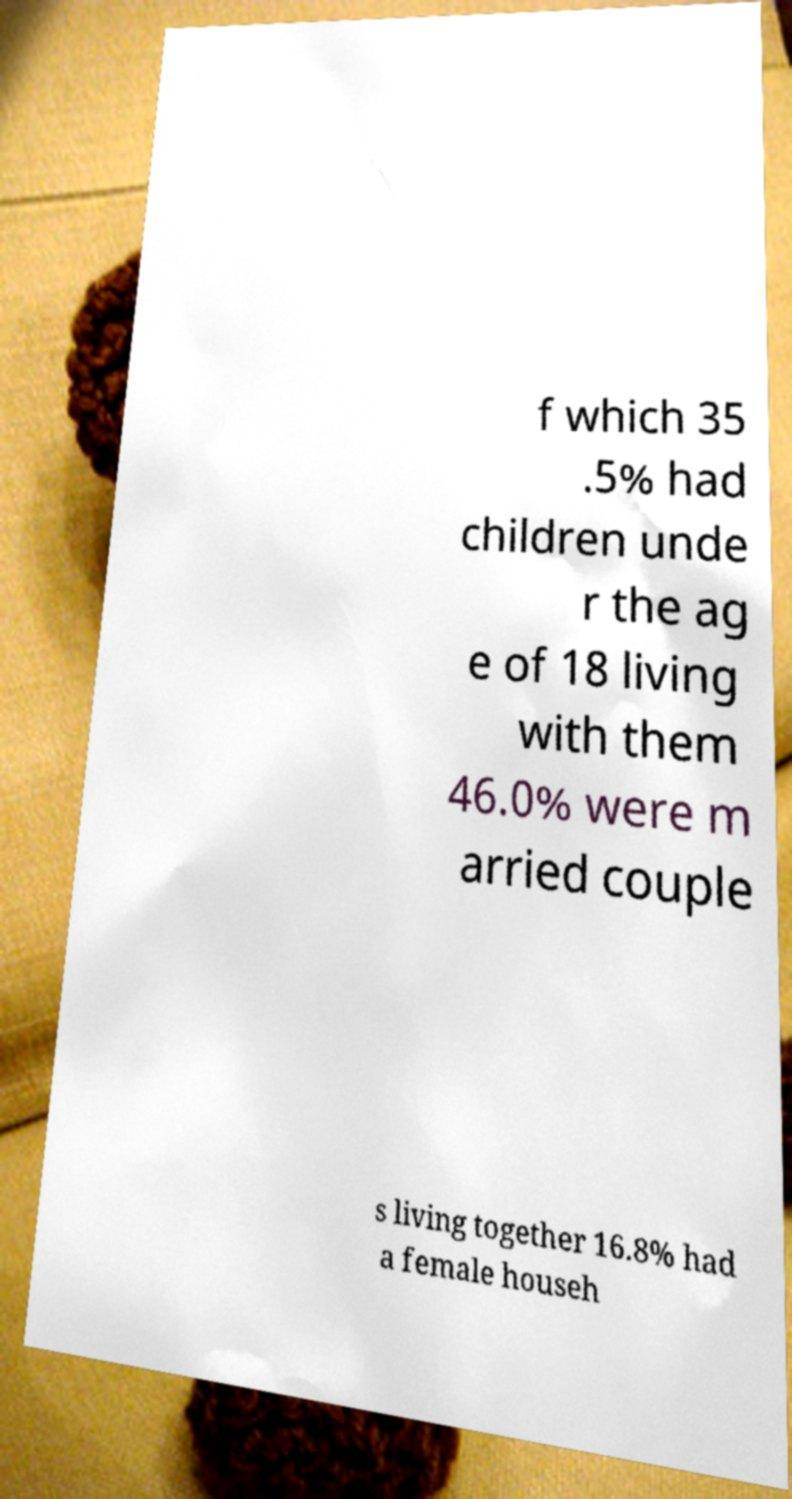There's text embedded in this image that I need extracted. Can you transcribe it verbatim? f which 35 .5% had children unde r the ag e of 18 living with them 46.0% were m arried couple s living together 16.8% had a female househ 